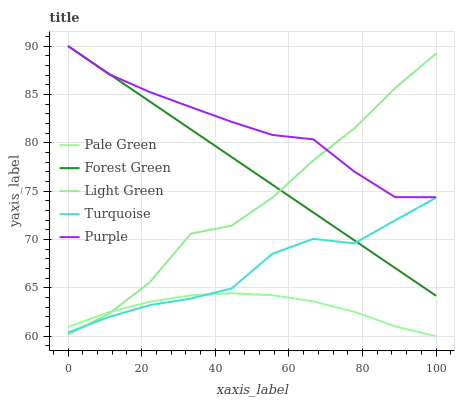Does Pale Green have the minimum area under the curve?
Answer yes or no. Yes. Does Purple have the maximum area under the curve?
Answer yes or no. Yes. Does Forest Green have the minimum area under the curve?
Answer yes or no. No. Does Forest Green have the maximum area under the curve?
Answer yes or no. No. Is Forest Green the smoothest?
Answer yes or no. Yes. Is Light Green the roughest?
Answer yes or no. Yes. Is Pale Green the smoothest?
Answer yes or no. No. Is Pale Green the roughest?
Answer yes or no. No. Does Pale Green have the lowest value?
Answer yes or no. Yes. Does Forest Green have the lowest value?
Answer yes or no. No. Does Forest Green have the highest value?
Answer yes or no. Yes. Does Pale Green have the highest value?
Answer yes or no. No. Is Pale Green less than Forest Green?
Answer yes or no. Yes. Is Forest Green greater than Pale Green?
Answer yes or no. Yes. Does Turquoise intersect Light Green?
Answer yes or no. Yes. Is Turquoise less than Light Green?
Answer yes or no. No. Is Turquoise greater than Light Green?
Answer yes or no. No. Does Pale Green intersect Forest Green?
Answer yes or no. No. 